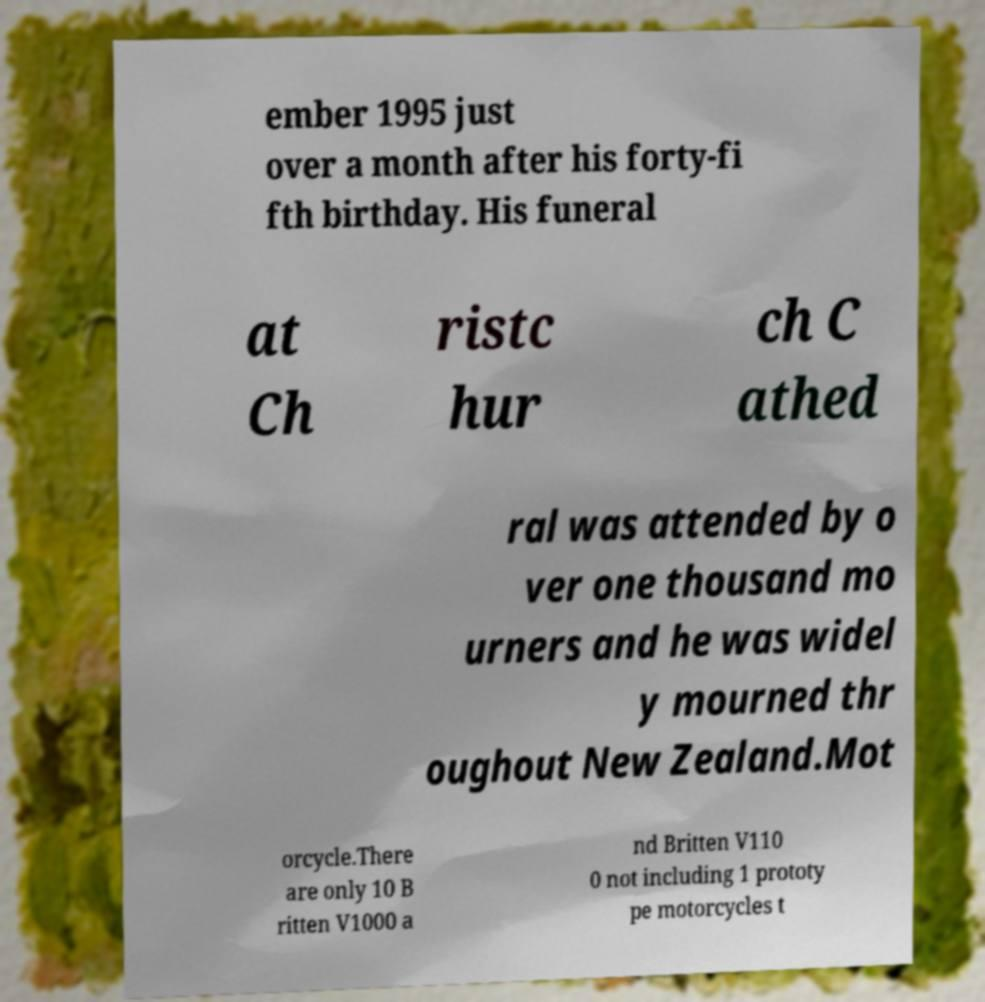There's text embedded in this image that I need extracted. Can you transcribe it verbatim? ember 1995 just over a month after his forty-fi fth birthday. His funeral at Ch ristc hur ch C athed ral was attended by o ver one thousand mo urners and he was widel y mourned thr oughout New Zealand.Mot orcycle.There are only 10 B ritten V1000 a nd Britten V110 0 not including 1 prototy pe motorcycles t 